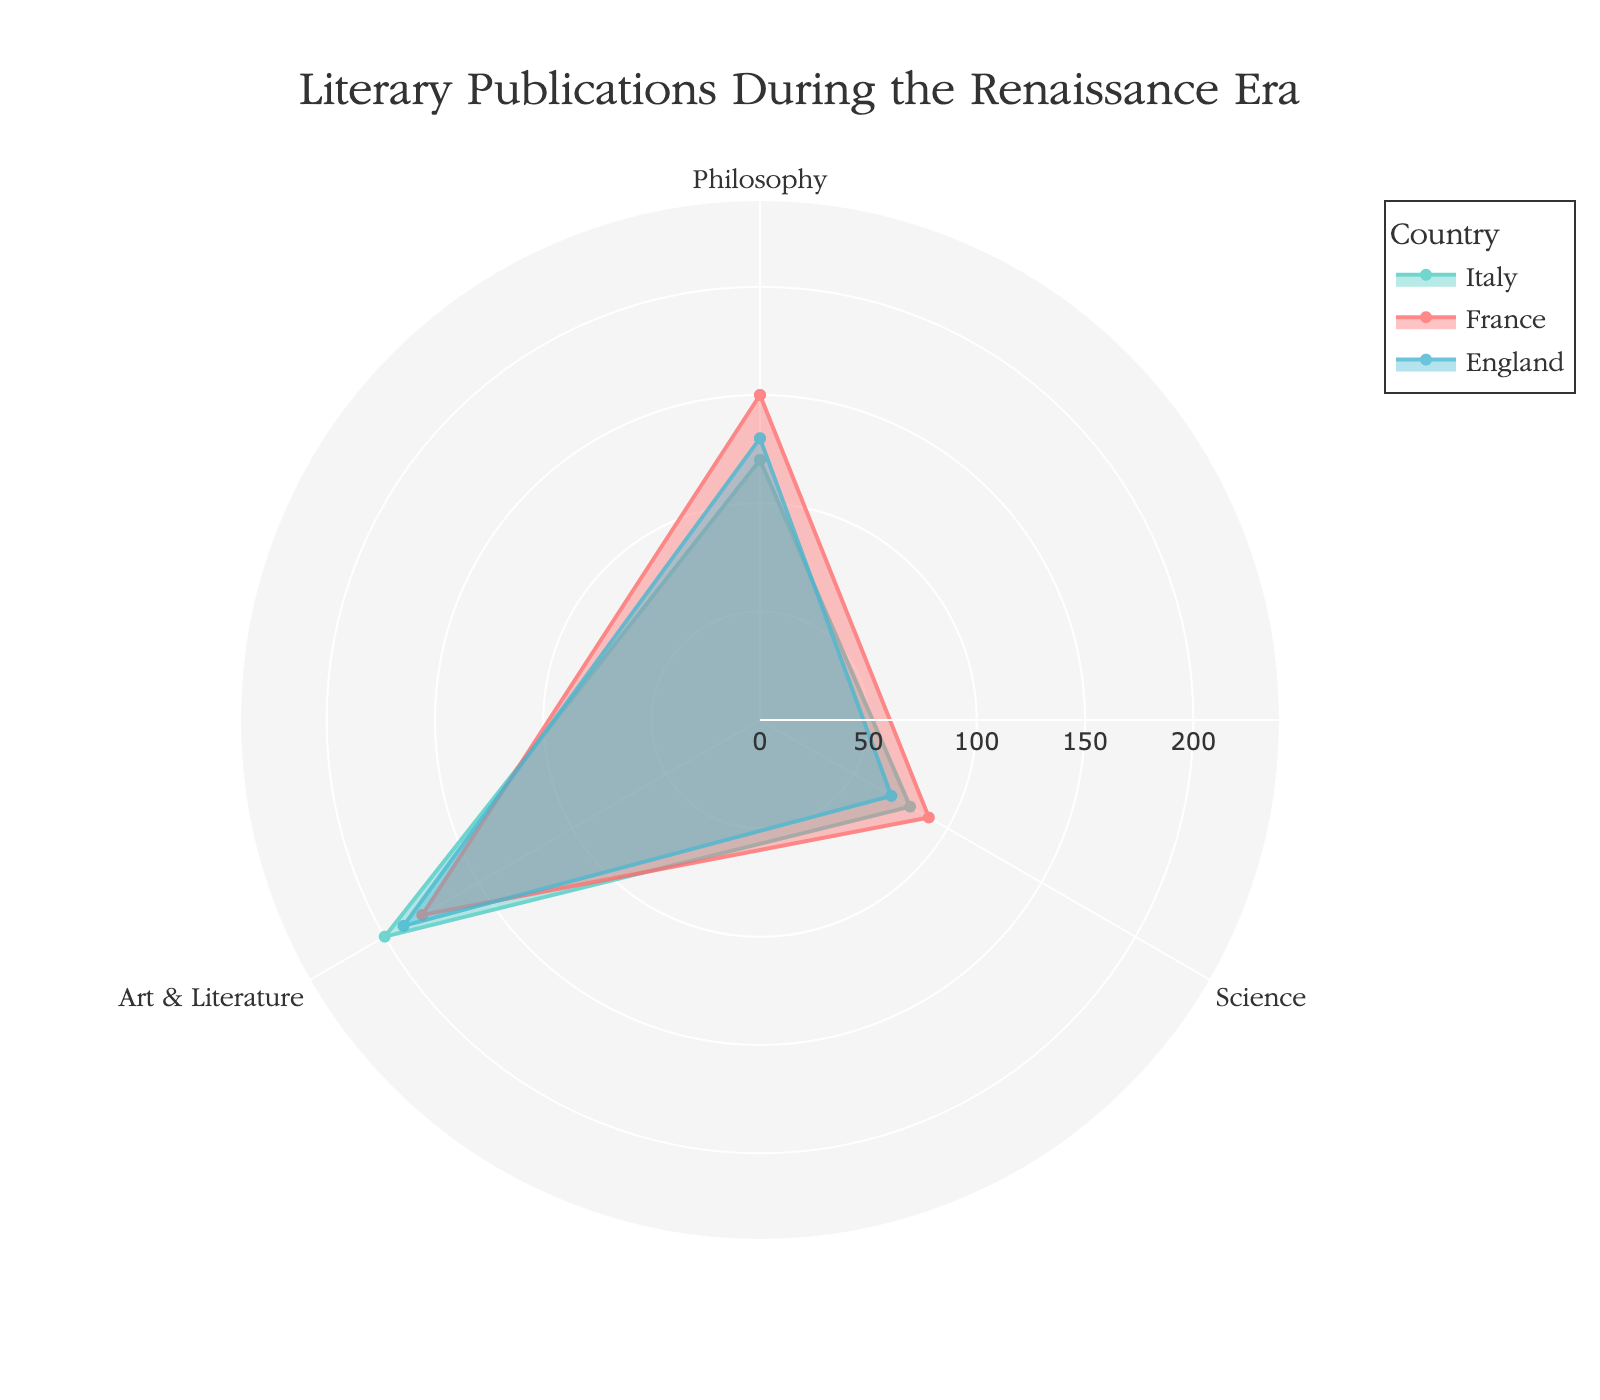what are the three categories represented in the chart? The titles representing different categories are visible where the axes of the rose chart intersect the outer boundary. They are distinctively marked.
Answer: Philosophy, Science, Art & Literature Which country has the highest count of Art & Literature publications? By observing the length of the data point corresponding to "Art & Literature" for each country, the one with the longest segment represents the highest count.
Answer: Italy How many philosophical publications were there in total across all countries? Add up the counts of philosophical publications for Italy, France, and England. The counts are 120 (Italy), 150 (France), and 130 (England). Summing them, we get 120 + 150 + 130 = 400.
Answer: 400 Which country exhibited the lowest number of Science publications? By comparing the lengths of the "Science" segments for each country, the shortest segment represents the lowest count. Observing the chart, England has the shortest segment in this category.
Answer: England How does the count of Science publications in France compare with the count in England? The length of the "Science" segment for France should be compared to that for England. France has 90, while England has 70 publications.
Answer: France has more In which category do Italy and France have the smallest difference in publication counts? To find the smallest difference, calculate the absolute differences between Italy's and France's publication counts for each category: Philosophy (150-120=30), Science (90-80=10), Art & Literature (200-180=20). The smallest value is 10 in the "Science" category.
Answer: Science What is the total number of publications in Italy? Add up the counts of all categories for Italy: Philosophy (120), Science (80), and Art & Literature (200). Summing these values, we get 120 + 80 + 200 = 400.
Answer: 400 Compare the publication counts in Philosophy between France and Italy. Which country has more? Observe the lengths of the segments in the "Philosophy" category for both countries. France has 150 while Italy has 120.
Answer: France What is the per-category average count of publications for England? To find the average, sum the counts for England's categories and divide by the number of categories: (130 + 70 + 190) / 3 = 390 / 3 = 130.
Answer: 130 Which country stands out in the chart for having the highest diversity in publication counts across different categories? Diversity can be inferred from the range between the highest and lowest counts for each country. Italy's counts are 120 (Philosophy), 80 (Science), and 200 (Art & Literature), with a range of 200 - 80 = 120. France's counts are 150 (Philosophy), 90 (Science), and 180 (Art & Literature), with a range of 180 - 90 = 90. England's counts are 130 (Philosophy), 70 (Science), and 190 (Art & Literature), with a range of 190 - 70 = 120. Both Italy and England have the highest range, but Italy has the widest range visually as observed.
Answer: Italy 